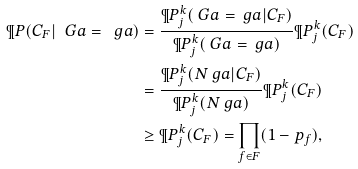<formula> <loc_0><loc_0><loc_500><loc_500>\P P ( C _ { F } | \ G a = \ g a ) & = \frac { \P P ^ { k } _ { j } ( \ G a = \ g a | C _ { F } ) } { \P P ^ { k } _ { j } ( \ G a = \ g a ) } { \P P ^ { k } _ { j } ( C _ { F } ) } \\ & = \frac { \P P ^ { k } _ { j } ( N _ { \ } g a | C _ { F } ) } { \P P ^ { k } _ { j } ( N _ { \ } g a ) } \P P ^ { k } _ { j } ( C _ { F } ) \\ & \geq \P P ^ { k } _ { j } ( C _ { F } ) = \prod _ { f \in F } ( 1 - p _ { f } ) ,</formula> 